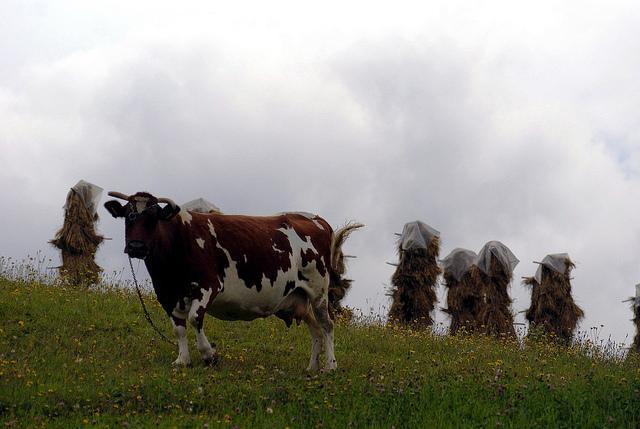How many animals are in this scene?
Give a very brief answer. 1. How many cows are here?
Give a very brief answer. 1. 